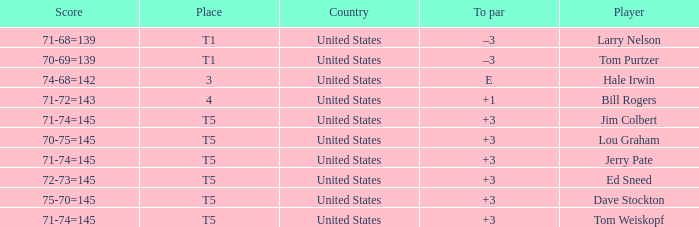What is the to par of player ed sneed, who has a t5 place? 3.0. 